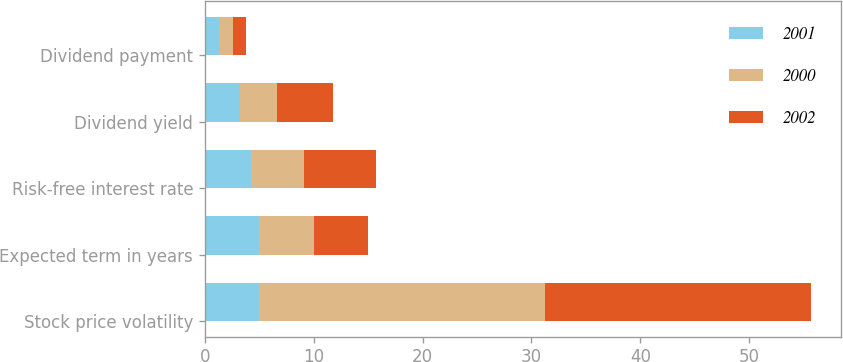<chart> <loc_0><loc_0><loc_500><loc_500><stacked_bar_chart><ecel><fcel>Stock price volatility<fcel>Expected term in years<fcel>Risk-free interest rate<fcel>Dividend yield<fcel>Dividend payment<nl><fcel>2001<fcel>4.95<fcel>5<fcel>4.2<fcel>3.2<fcel>1.32<nl><fcel>2000<fcel>26.3<fcel>5<fcel>4.9<fcel>3.4<fcel>1.26<nl><fcel>2002<fcel>24.4<fcel>5<fcel>6.6<fcel>5.2<fcel>1.2<nl></chart> 